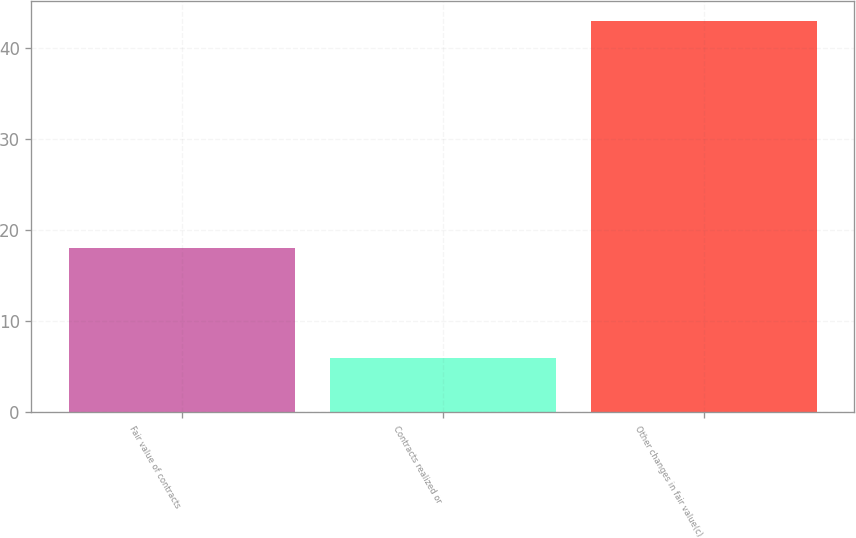Convert chart to OTSL. <chart><loc_0><loc_0><loc_500><loc_500><bar_chart><fcel>Fair value of contracts<fcel>Contracts realized or<fcel>Other changes in fair value(c)<nl><fcel>18<fcel>6<fcel>43<nl></chart> 